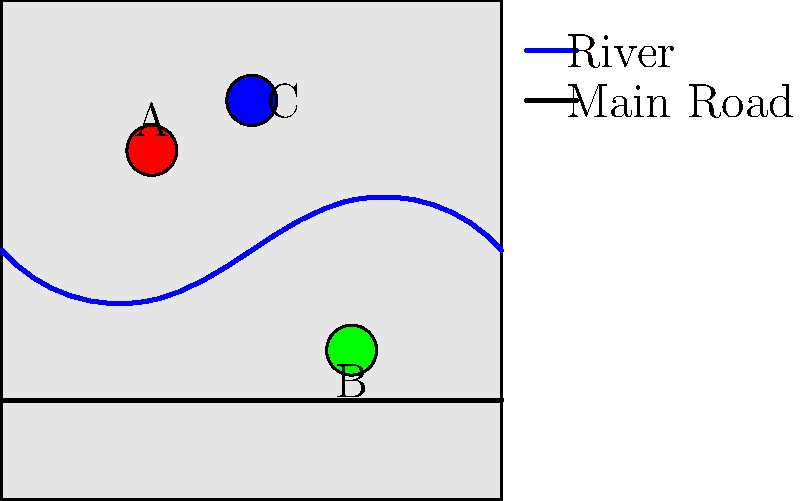Based on the simplified map of Leyburn shown above, which landmark is most likely to represent Bolton Castle? To answer this question, we need to consider the geographical features and landmarks of Leyburn and the surrounding Wensleydale area:

1. The map shows three main landmarks (A, B, and C) along with a river and a main road.

2. Bolton Castle is a significant landmark in Wensleydale, located to the west of Leyburn.

3. The River Ure flows through Wensleydale, generally from west to east.

4. The main road in the area is the A684, which runs roughly parallel to the river.

5. Looking at the map:
   - Landmark A is north of the river and close to it.
   - Landmark B is south of both the river and the main road.
   - Landmark C is the northernmost point, far from both the river and the road.

6. Given Bolton Castle's actual location:
   - It is situated north of the River Ure.
   - It is relatively close to the river.
   - It is not directly on the main road.

7. Based on these considerations, Landmark A best matches the likely position of Bolton Castle on this simplified map.
Answer: A 